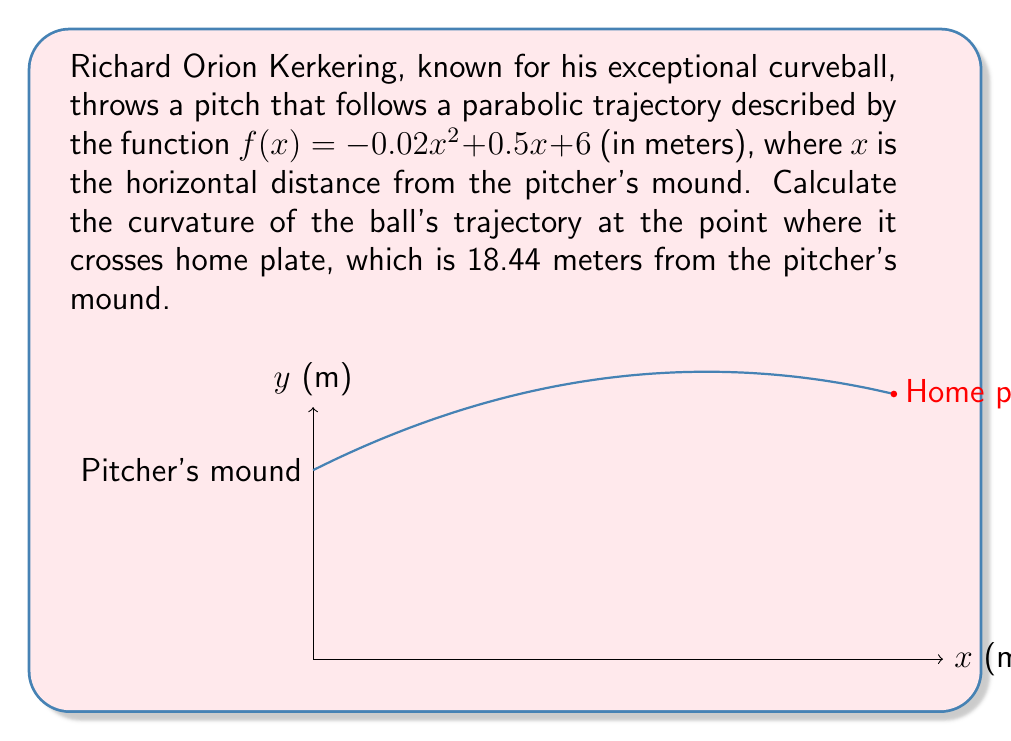Could you help me with this problem? To calculate the curvature of the baseball's trajectory, we'll use the formula for the curvature of a planar curve:

$$\kappa = \frac{|f''(x)|}{(1 + (f'(x))^2)^{3/2}}$$

Step 1: Find $f'(x)$ and $f''(x)$
$f'(x) = -0.04x + 0.5$
$f''(x) = -0.04$

Step 2: Evaluate $f'(x)$ at $x = 18.44$
$f'(18.44) = -0.04(18.44) + 0.5 = -0.2376$

Step 3: Substitute values into the curvature formula
$$\kappa = \frac{|-0.04|}{(1 + (-0.2376)^2)^{3/2}}$$

Step 4: Calculate the result
$$\kappa = \frac{0.04}{(1 + 0.0564)^{3/2}} = \frac{0.04}{1.0857} \approx 0.0368 \text{ m}^{-1}$$

This curvature value represents the reciprocal of the radius of the osculating circle at the given point, indicating how sharply the trajectory is curving at home plate.
Answer: $0.0368 \text{ m}^{-1}$ 